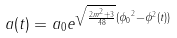<formula> <loc_0><loc_0><loc_500><loc_500>a ( t ) = a _ { 0 } e ^ { \sqrt { \frac { 2 m ^ { 2 } + 3 } { 4 8 } } ( { \phi _ { 0 } } ^ { 2 } - \phi ^ { 2 } ( t ) ) }</formula> 